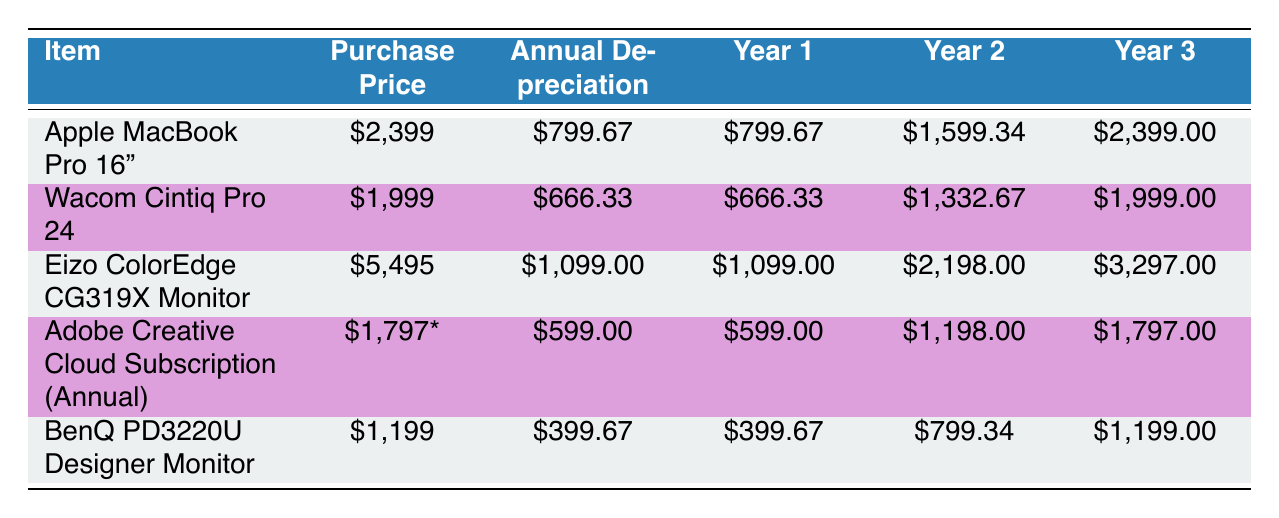What is the annual depreciation for the Apple MacBook Pro 16"? According to the table, the annual depreciation for the Apple MacBook Pro 16" is listed in the corresponding column, which shows $799.67
Answer: 799.67 What is the total accumulated depreciation for the Wacom Cintiq Pro 24 after three years? The accumulated depreciation for the Wacom Cintiq Pro 24 after three years is found in the last column of its row, showing $1,999
Answer: 1999 Which item has the highest purchase price? By comparing the purchase prices of all items listed, the Eizo ColorEdge CG319X Monitor has the highest price at $5,495
Answer: 5495 What is the average annual depreciation for all items listed? To find the average, first add the annual depreciation values: 799.67 + 666.33 + 1,099 + 599 + 399.67 = 3,564.67. Then divide by the number of items (5): 3,564.67 / 5 = 712.93
Answer: 712.93 Is the accumulated depreciation for the Adobe Creative Cloud Subscription in Year 2 $1,198? The table shows the accumulated depreciation for the Adobe Creative Cloud Subscription in Year 2 is indeed $1,198. Therefore, the statement is true
Answer: Yes How much more is the accumulated depreciation for the Eizo ColorEdge CG319X Monitor in Year 3 than in Year 1? The accumulated depreciation in Year 3 for the Eizo ColorEdge CG319X Monitor is $3,297 and in Year 1 it is $1,099. The difference is calculated as $3,297 - $1,099 = $2,198
Answer: 2198 What is the total depreciation expense for all items in Year 1? The total depreciation expense for Year 1 is the sum of each item's annual depreciation in Year 1: 799.67 + 666.33 + 1,099 + 599 + 399.67 = 3,564.67
Answer: 3564.67 Which item has the lowest annual depreciation? By reviewing the annual depreciation values listed, the BenQ PD3220U Designer Monitor has the lowest at $399.67
Answer: 399.67 If I add the purchase prices of the Apple MacBook Pro 16" and the Wacom Cintiq Pro 24, what is the total? The purchase price of the Apple MacBook Pro 16" is $2,399, and the Wacom Cintiq Pro 24 is $1,999. The total is $2,399 + $1,999 = $4,398
Answer: 4398 